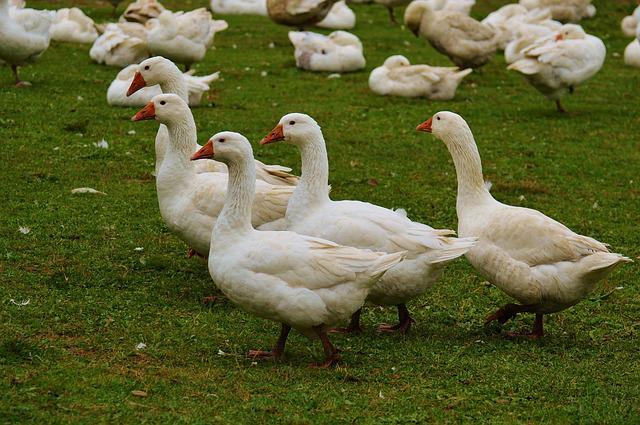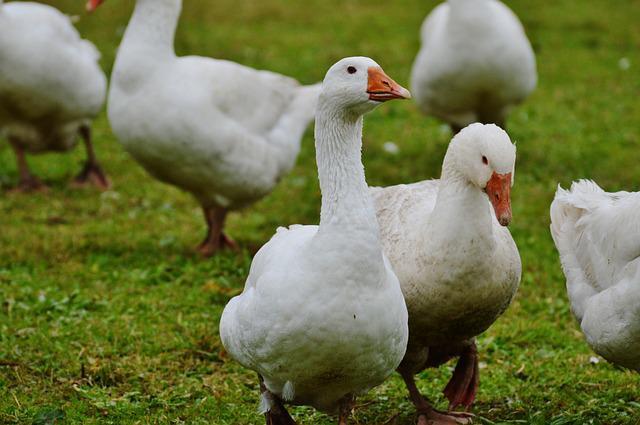The first image is the image on the left, the second image is the image on the right. For the images displayed, is the sentence "There are exactly three ducks in the left image." factually correct? Answer yes or no. No. The first image is the image on the left, the second image is the image on the right. For the images shown, is this caption "There are more birds in the image on the left than in the image on the right." true? Answer yes or no. Yes. 